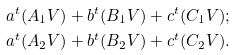<formula> <loc_0><loc_0><loc_500><loc_500>a ^ { t } ( A _ { 1 } V ) + b ^ { t } ( B _ { 1 } V ) + c ^ { t } ( C _ { 1 } V ) ; \\ a ^ { t } ( A _ { 2 } V ) + b ^ { t } ( B _ { 2 } V ) + c ^ { t } ( C _ { 2 } V ) .</formula> 